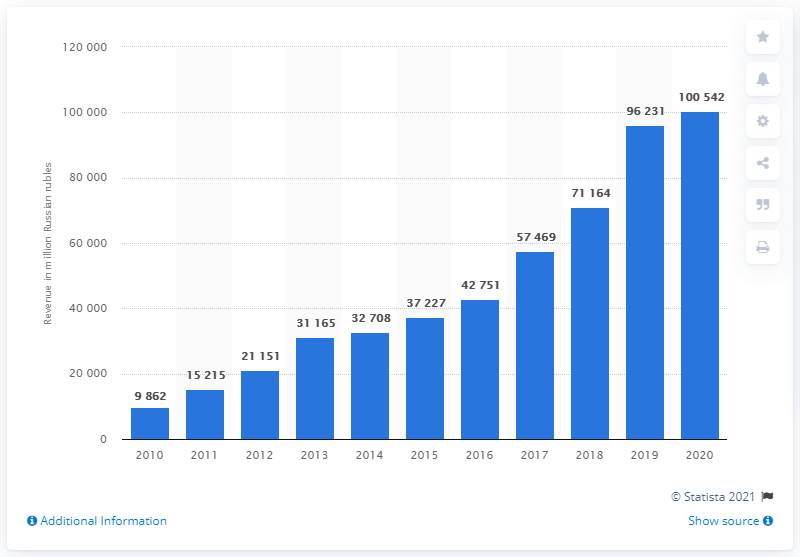Point out several critical features in this image. In 2020, the Mail.ru Group generated approximately 100,542 revenue in Russia. 